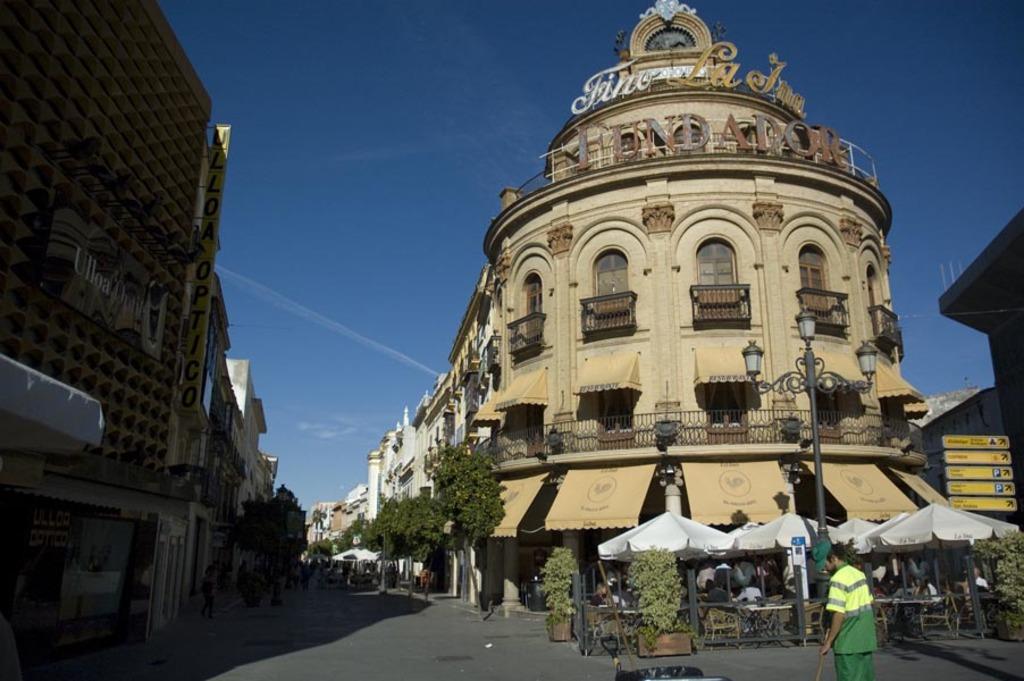How would you summarize this image in a sentence or two? In this image, we can see so many buildings with walls, windows, railings. Here we can see sign boards, poles, lights, trees, plants, few people, road, chairs, tables, hoardings, stalls. Background there is a sky. 